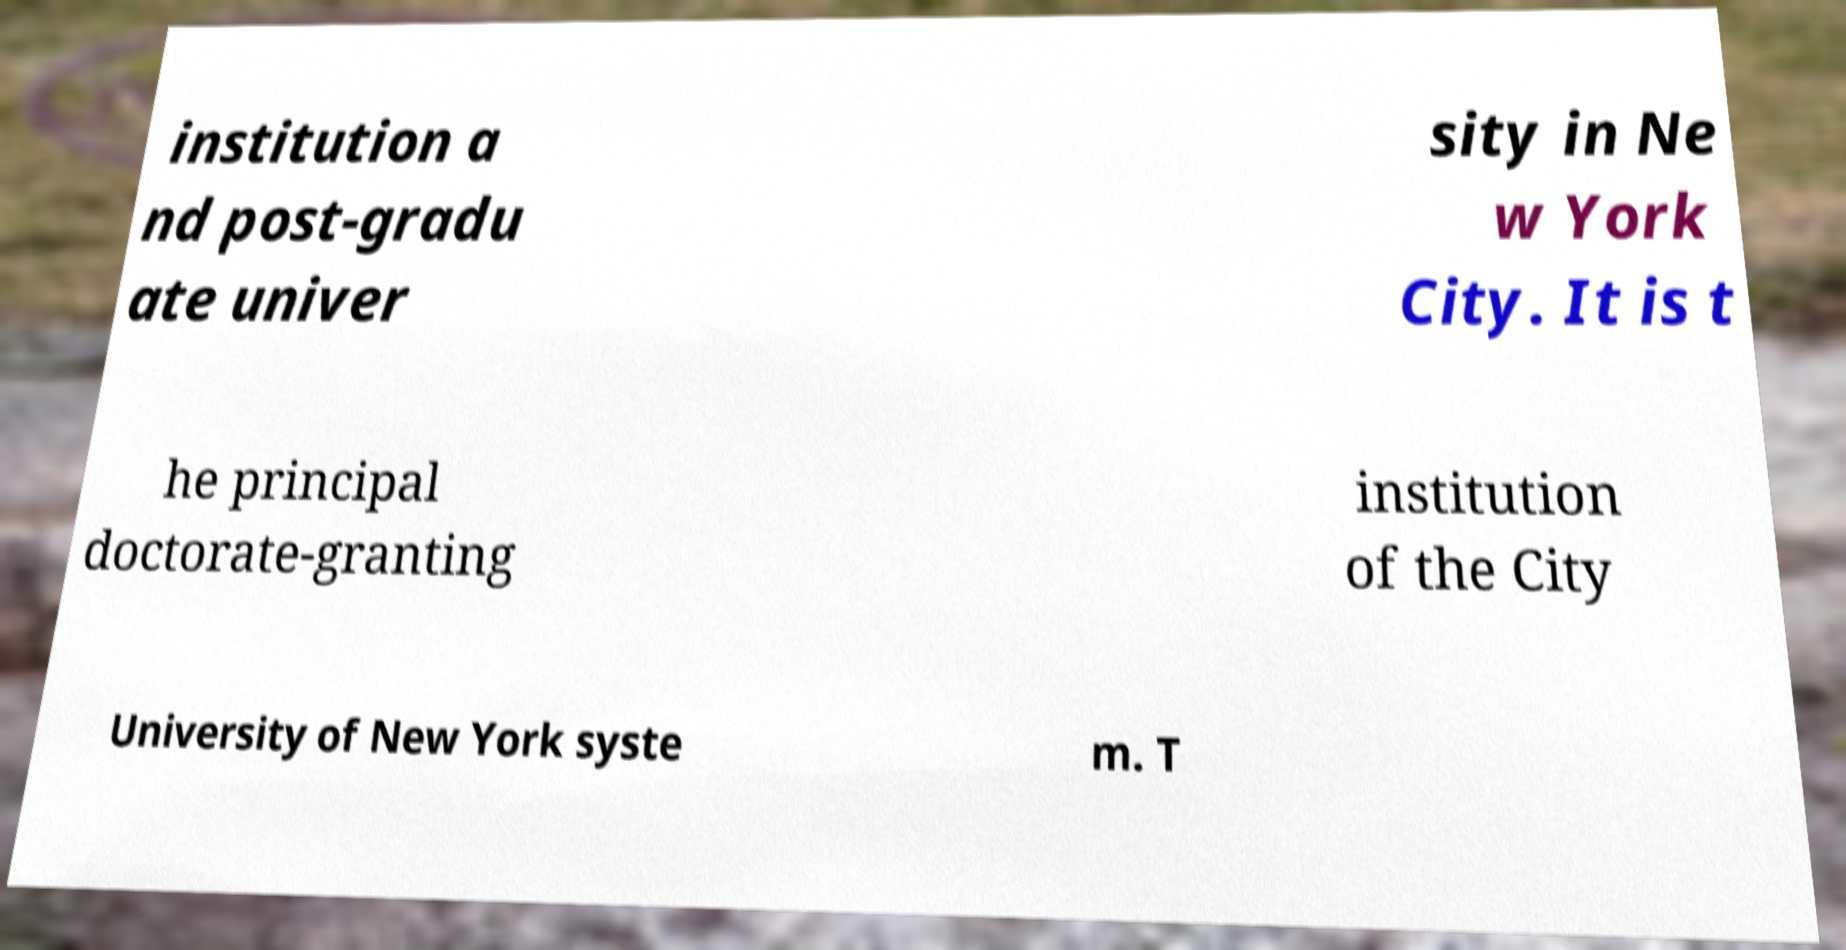Could you assist in decoding the text presented in this image and type it out clearly? institution a nd post-gradu ate univer sity in Ne w York City. It is t he principal doctorate-granting institution of the City University of New York syste m. T 